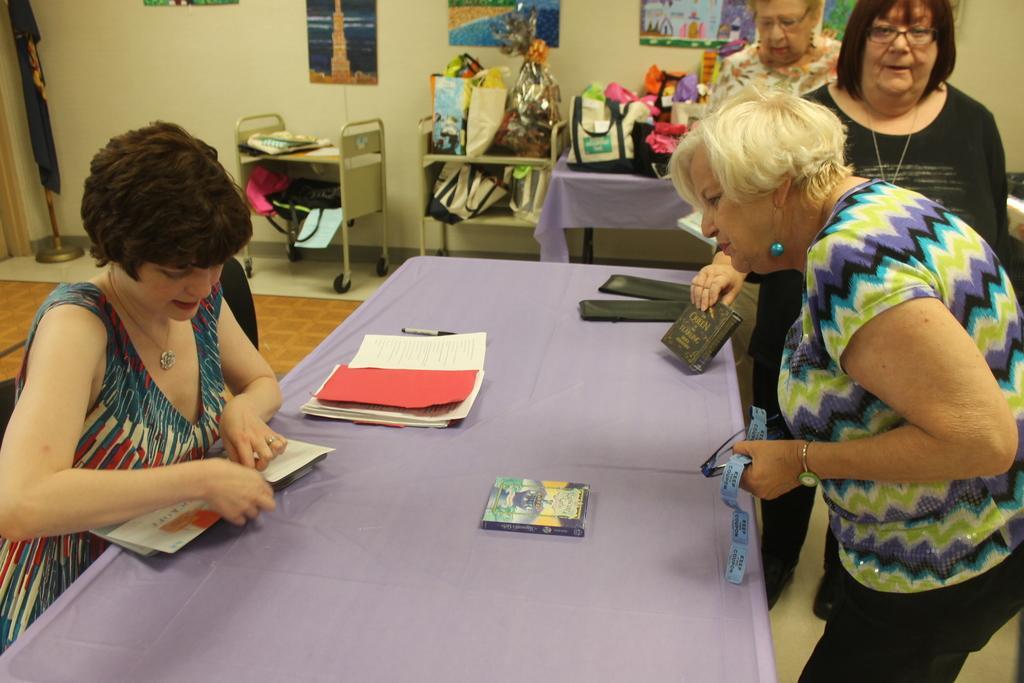Please provide a concise description of this image. This Picture Describe about four old ladies who is setting in the hall, we can see blue color long table and lady wearing colorful dress sitting on the chair and opening the envelope. Opposite to her a old lady wearing colorful dress holding a tickets in the hand watching the envelope. Behind a lady wearing black t- shirt is passing by holding a book in the hand. Behind we can see a number of gifts packs on the table and poster, frame on the wall. 